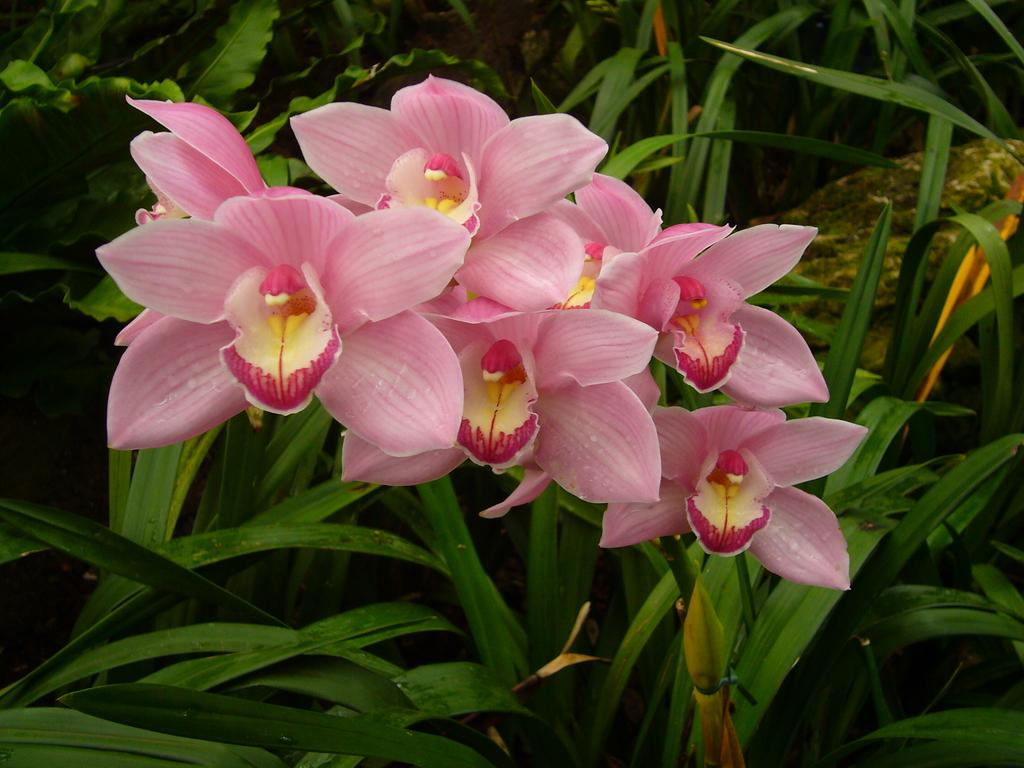What type of flowers can be seen in the image? There are pink flowers in the image. Where are the flowers located? The flowers are on a plant. Are there any cobwebs visible in the image? There is no mention of cobwebs in the provided facts, so we cannot determine if any are present in the image. 